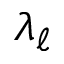<formula> <loc_0><loc_0><loc_500><loc_500>\lambda _ { \ell }</formula> 